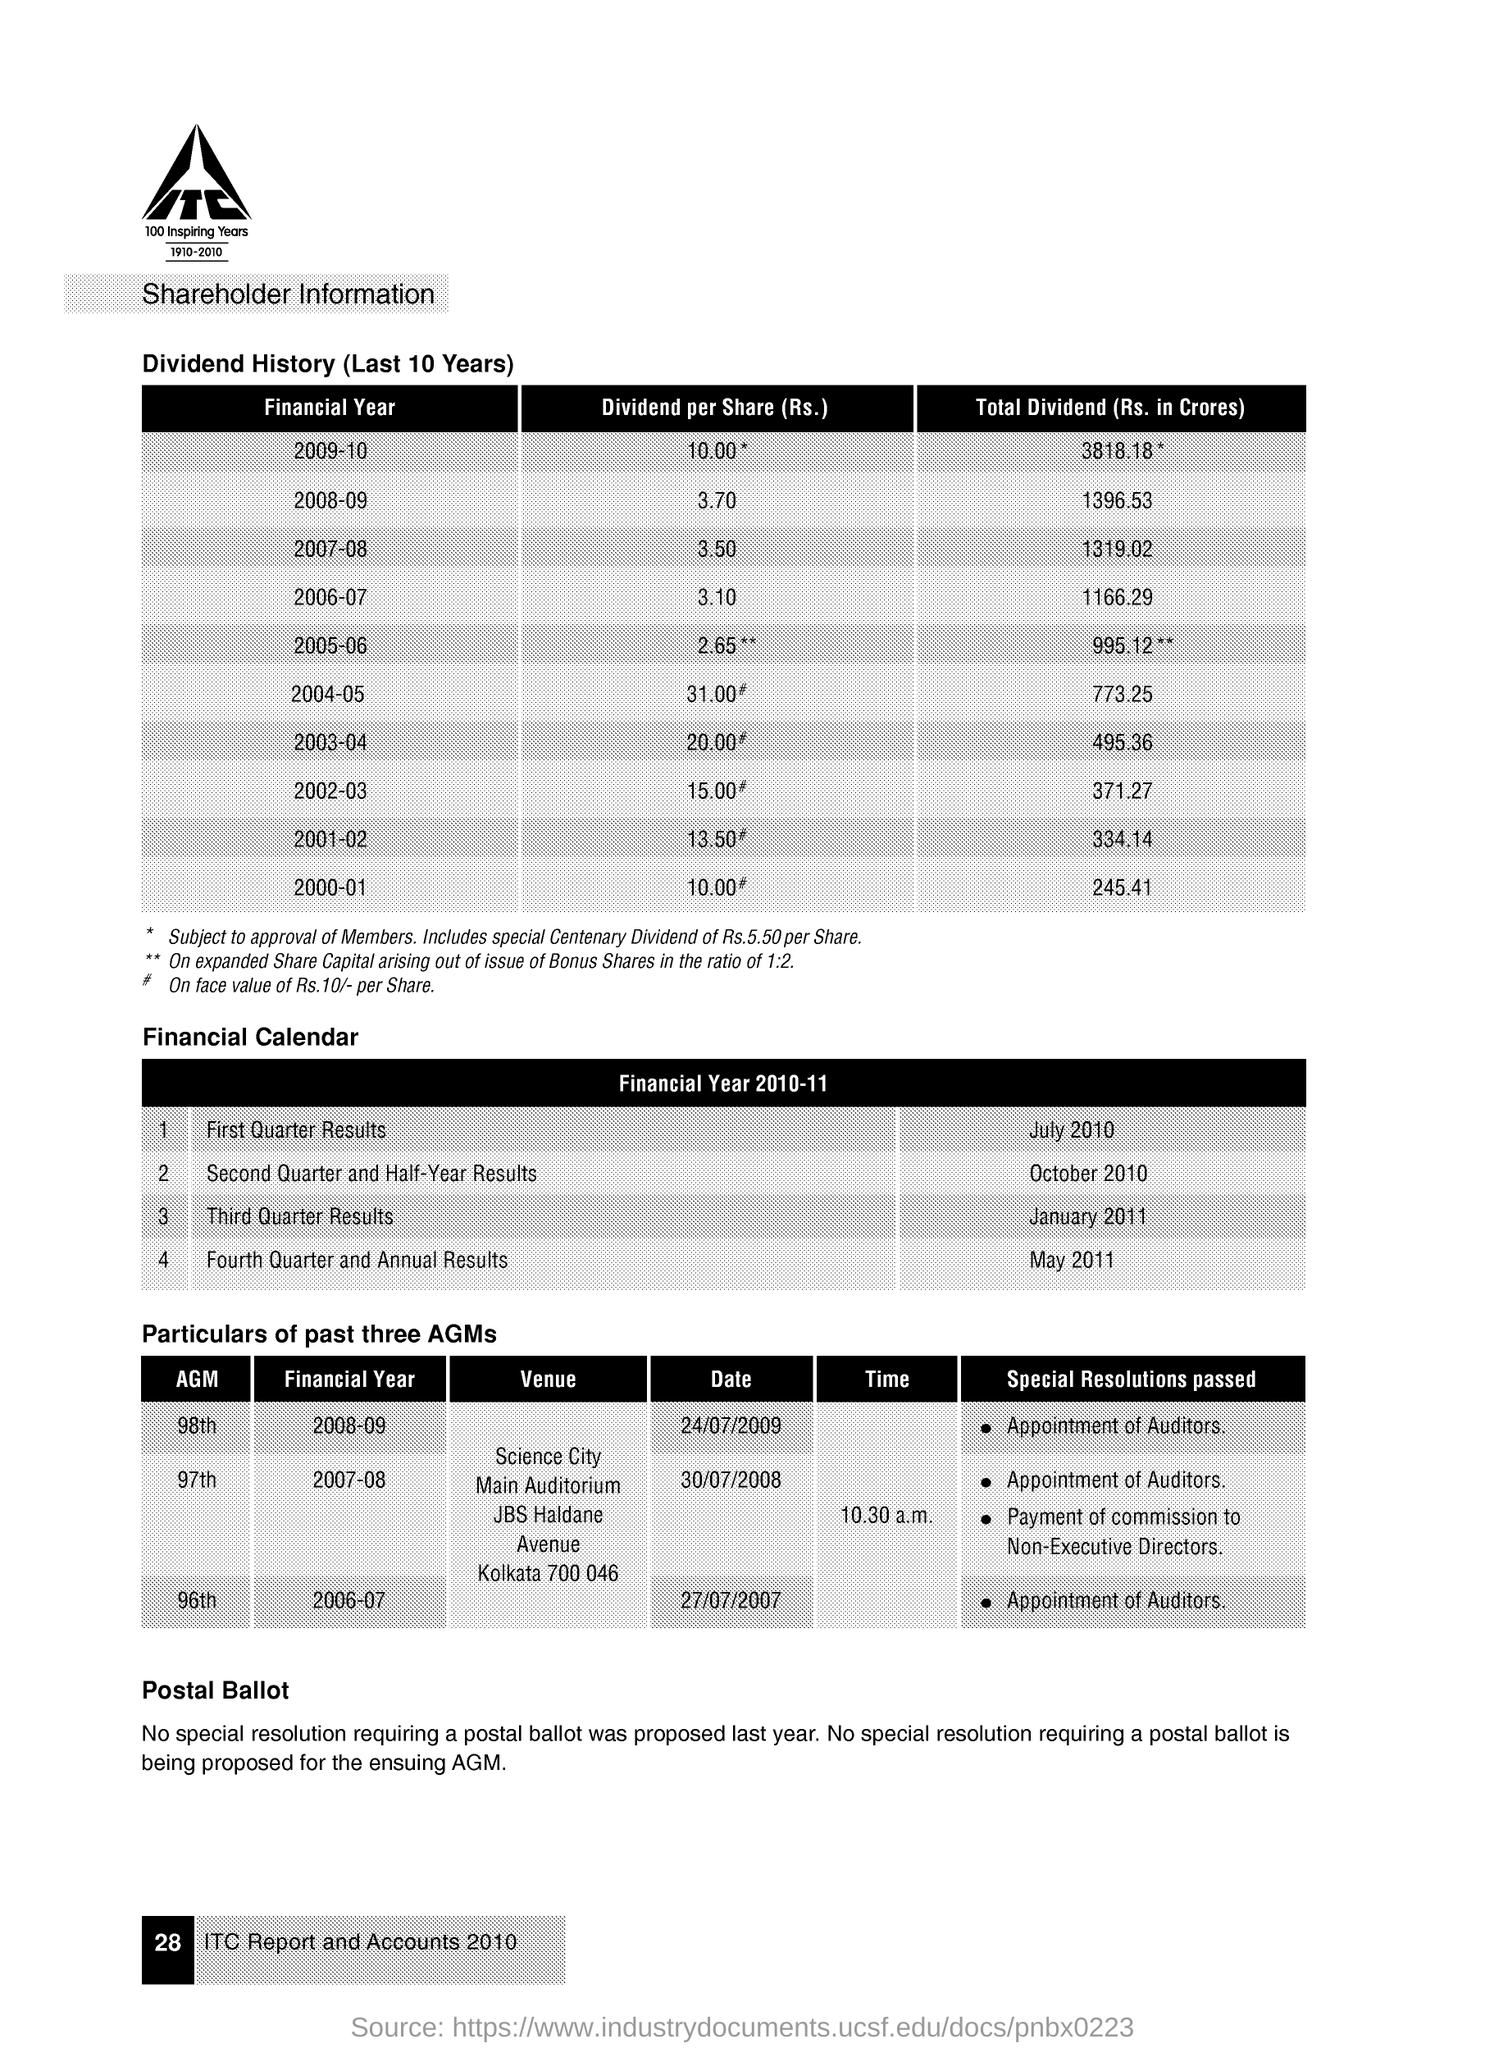What does the asterisk notation signify in the context of the dividend history shown in the image? In the context of the provided share dividend history, the asterisk notation typically signifies notes or special conditions related to the figures. For example, the single asterisk next to the 2009-10 dividend per share and total dividend indicates these figures are 'subject to approval of Members,' and the double asterisks for 2005-06 indicate an expanded share capital due to the issue of bonus shares in the ratio of 1:2. 